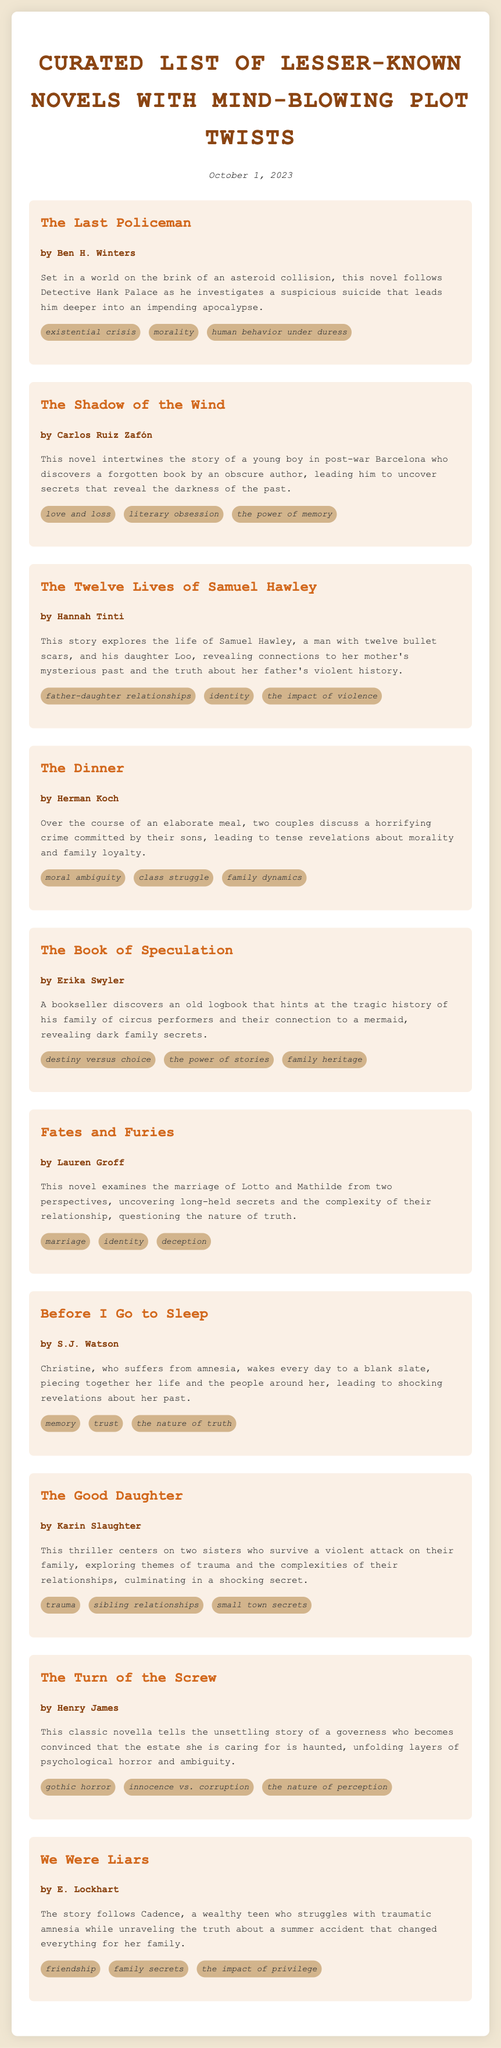What is the title of the first novel listed? The first novel is "The Last Policeman."
Answer: The Last Policeman Who is the author of "The Shadow of the Wind"? The author of "The Shadow of the Wind" is Carlos Ruiz Zafón.
Answer: Carlos Ruiz Zafón How many novels are listed in the document? The document features a total of ten novels.
Answer: Ten What theme is associated with "Before I Go to Sleep"? The themes listed for "Before I Go to Sleep" include memory, trust, and the nature of truth.
Answer: Memory What is the central focus of "The Dinner"? The central focus is a discussion about a horrifying crime committed by their sons.
Answer: A horrifying crime Which novel features a character with twelve bullet scars? "The Twelve Lives of Samuel Hawley" features a character with twelve bullet scars.
Answer: The Twelve Lives of Samuel Hawley What is a key theme of "We Were Liars"? A key theme is family secrets.
Answer: Family secrets Who is the protagonist in "The Good Daughter"? The protagonists are two sisters who survive a violent attack on their family.
Answer: Two sisters What genre does "The Turn of the Screw" belong to? "The Turn of the Screw" belongs to the gothic horror genre.
Answer: Gothic horror 